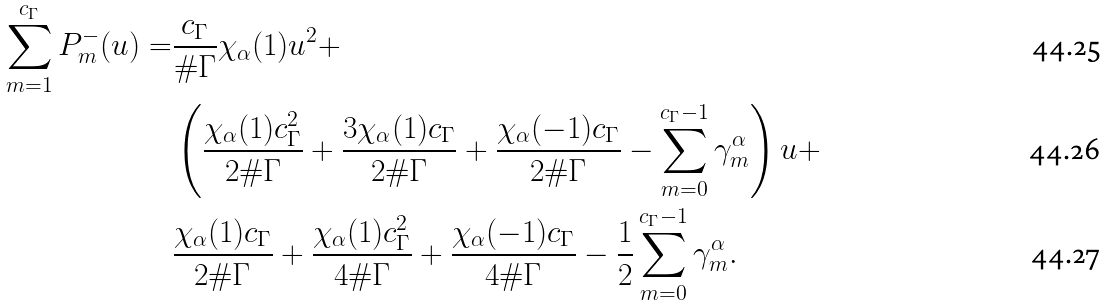Convert formula to latex. <formula><loc_0><loc_0><loc_500><loc_500>\sum _ { m = 1 } ^ { c _ { \Gamma } } P _ { m } ^ { - } ( u ) = & \frac { c _ { \Gamma } } { \# \Gamma } \chi _ { \alpha } ( 1 ) u ^ { 2 } + \\ & \left ( \frac { \chi _ { \alpha } ( 1 ) c _ { \Gamma } ^ { 2 } } { 2 \# \Gamma } + \frac { 3 \chi _ { \alpha } ( 1 ) c _ { \Gamma } } { 2 \# \Gamma } + \frac { \chi _ { \alpha } ( - 1 ) c _ { \Gamma } } { 2 \# \Gamma } - \sum _ { m = 0 } ^ { c _ { \Gamma } - 1 } \gamma _ { m } ^ { \alpha } \right ) u + \\ & \frac { \chi _ { \alpha } ( 1 ) c _ { \Gamma } } { 2 \# \Gamma } + \frac { \chi _ { \alpha } ( 1 ) c _ { \Gamma } ^ { 2 } } { 4 \# \Gamma } + \frac { \chi _ { \alpha } ( - 1 ) c _ { \Gamma } } { 4 \# \Gamma } - \frac { 1 } { 2 } \sum _ { m = 0 } ^ { c _ { \Gamma } - 1 } \gamma _ { m } ^ { \alpha } .</formula> 